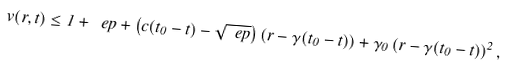Convert formula to latex. <formula><loc_0><loc_0><loc_500><loc_500>v ( r , t ) \leq 1 + \ e p + \left ( c ( t _ { 0 } - t ) - \sqrt { \ e p } \right ) ( r - \gamma ( t _ { 0 } - t ) ) + \gamma _ { 0 } \left ( r - \gamma ( t _ { 0 } - t ) \right ) ^ { 2 } ,</formula> 